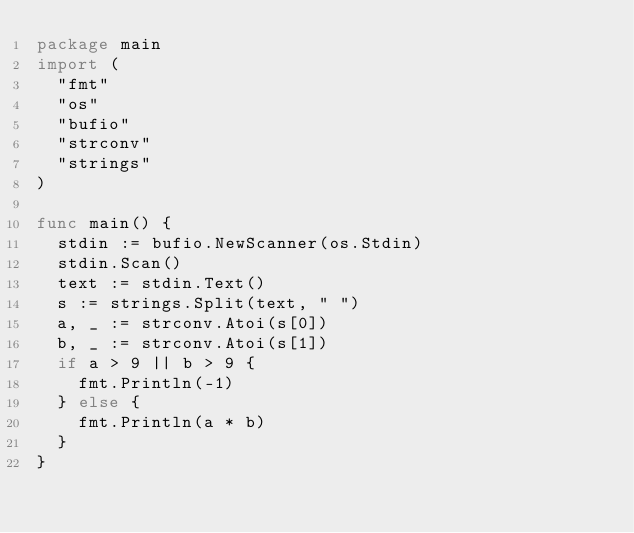Convert code to text. <code><loc_0><loc_0><loc_500><loc_500><_Go_>package main
import (
	"fmt"
	"os"
	"bufio"
	"strconv"
	"strings"
)
 
func main() {
	stdin := bufio.NewScanner(os.Stdin)
	stdin.Scan()
	text := stdin.Text()
	s := strings.Split(text, " ")
	a, _ := strconv.Atoi(s[0])
	b, _ := strconv.Atoi(s[1])
	if a > 9 || b > 9 {
		fmt.Println(-1)
	} else {
		fmt.Println(a * b)
	}
}</code> 